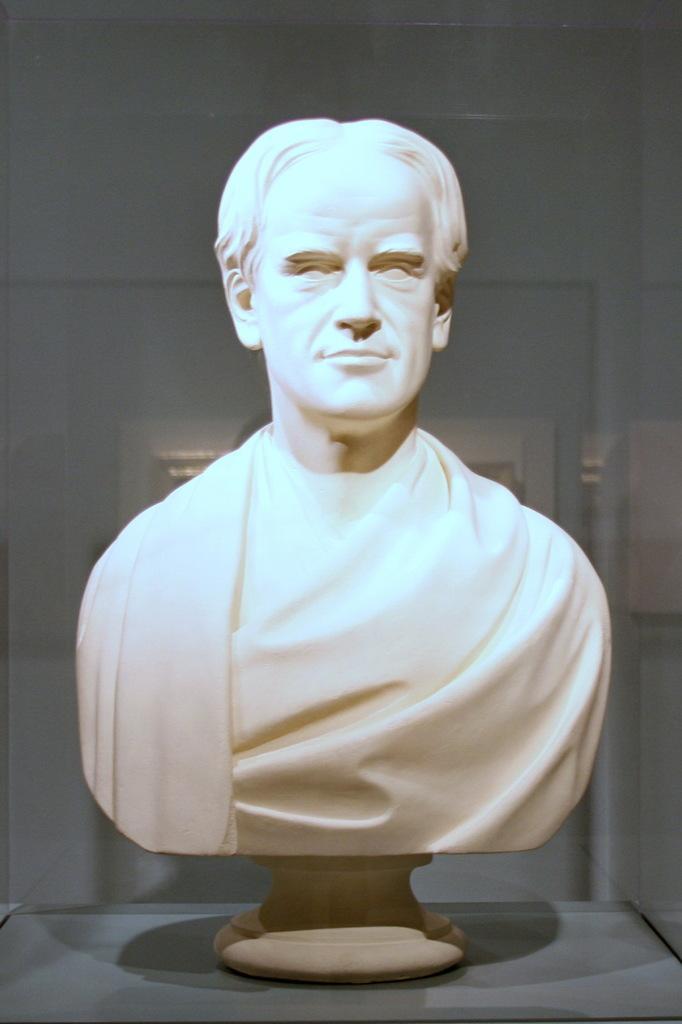How would you summarize this image in a sentence or two? In this picture there is a statue of a man which is kept on the box. 